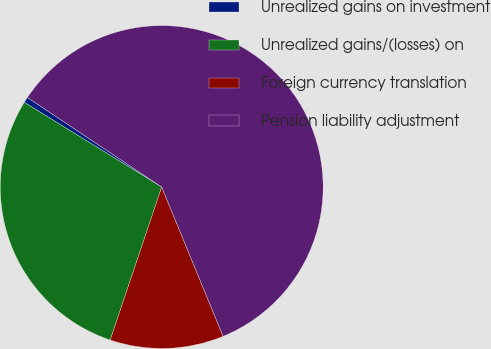Convert chart. <chart><loc_0><loc_0><loc_500><loc_500><pie_chart><fcel>Unrealized gains on investment<fcel>Unrealized gains/(losses) on<fcel>Foreign currency translation<fcel>Pension liability adjustment<nl><fcel>0.57%<fcel>28.62%<fcel>11.38%<fcel>59.43%<nl></chart> 